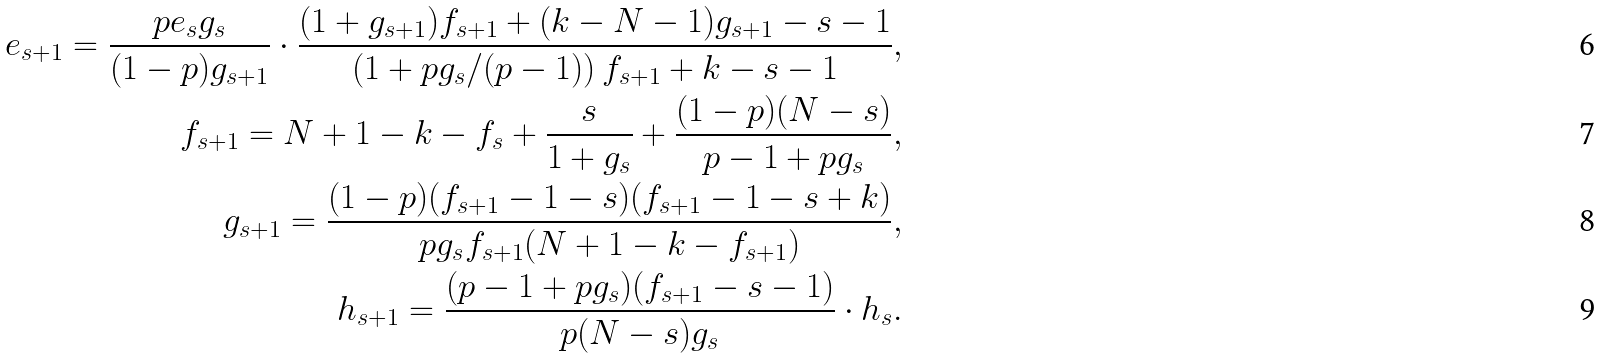<formula> <loc_0><loc_0><loc_500><loc_500>e _ { s + 1 } = \frac { p e _ { s } g _ { s } } { ( 1 - p ) g _ { s + 1 } } \cdot \frac { ( 1 + g _ { s + 1 } ) f _ { s + 1 } + ( k - N - 1 ) g _ { s + 1 } - s - 1 } { \left ( 1 + p g _ { s } / ( p - 1 ) \right ) f _ { s + 1 } + k - s - 1 } , \\ f _ { s + 1 } = N + 1 - k - f _ { s } + \frac { s } { 1 + g _ { s } } + \frac { ( 1 - p ) ( N - s ) } { p - 1 + p g _ { s } } , \\ g _ { s + 1 } = \frac { ( 1 - p ) ( f _ { s + 1 } - 1 - s ) ( f _ { s + 1 } - 1 - s + k ) } { p g _ { s } f _ { s + 1 } ( N + 1 - k - f _ { s + 1 } ) } , \\ h _ { s + 1 } = \frac { ( p - 1 + p g _ { s } ) ( f _ { s + 1 } - s - 1 ) } { p ( N - s ) g _ { s } } \cdot h _ { s } .</formula> 